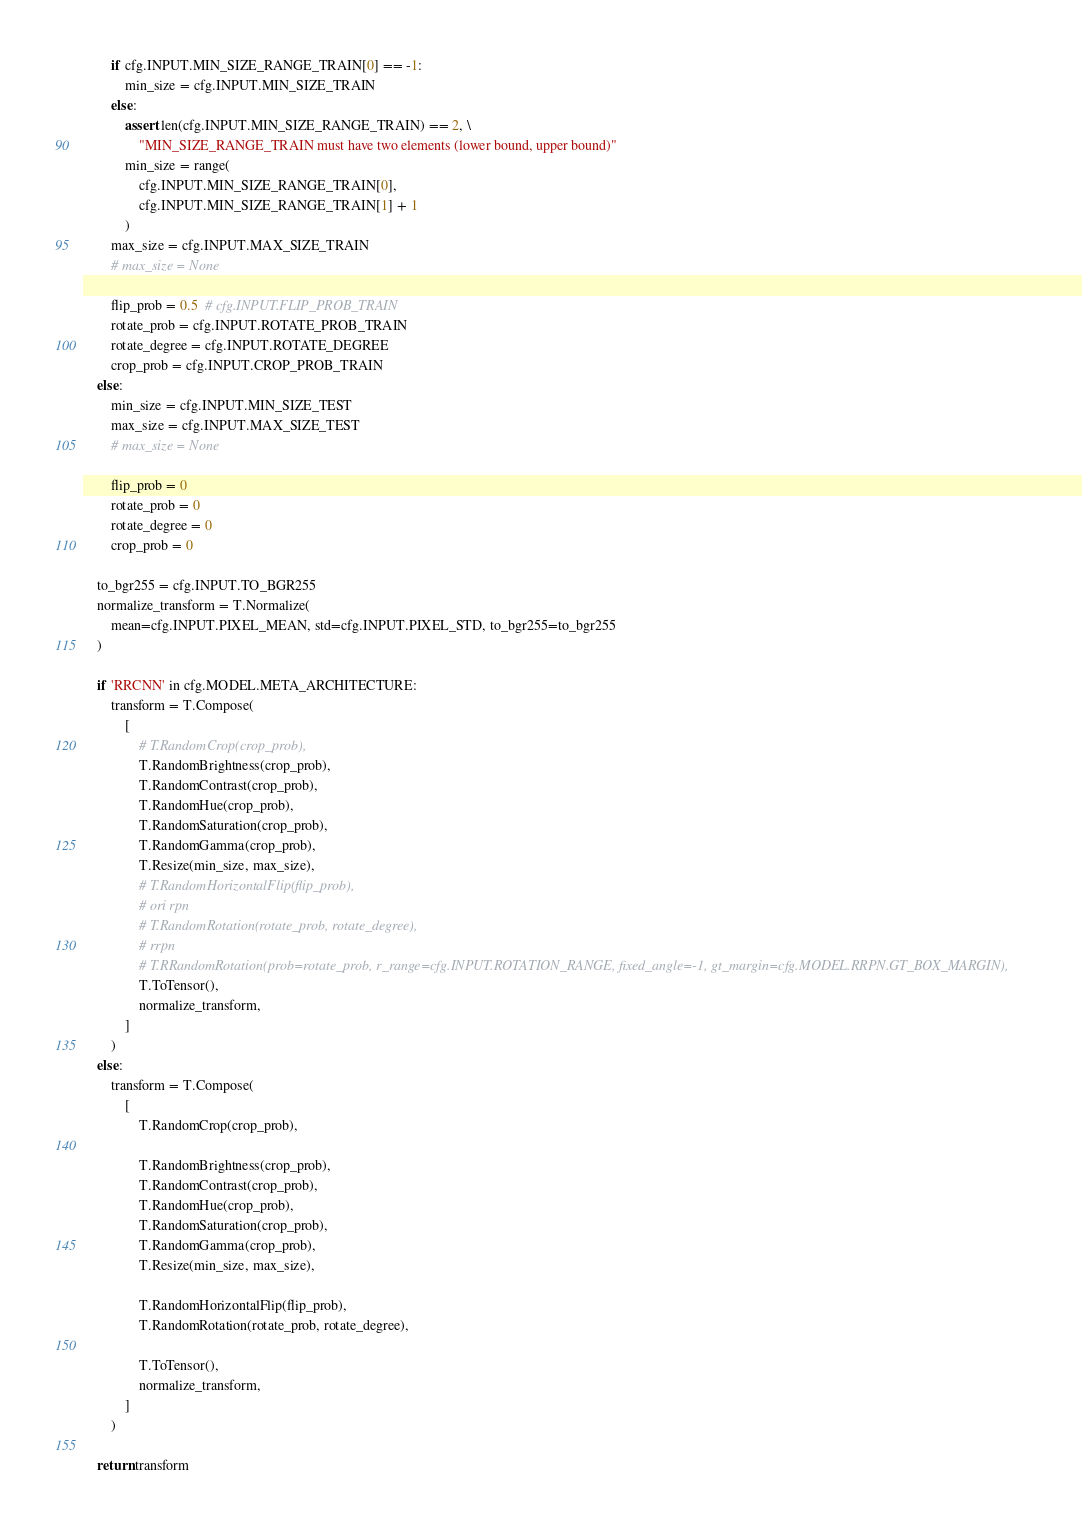<code> <loc_0><loc_0><loc_500><loc_500><_Python_>        if cfg.INPUT.MIN_SIZE_RANGE_TRAIN[0] == -1:
            min_size = cfg.INPUT.MIN_SIZE_TRAIN
        else:
            assert len(cfg.INPUT.MIN_SIZE_RANGE_TRAIN) == 2, \
                "MIN_SIZE_RANGE_TRAIN must have two elements (lower bound, upper bound)"
            min_size = range(
                cfg.INPUT.MIN_SIZE_RANGE_TRAIN[0],
                cfg.INPUT.MIN_SIZE_RANGE_TRAIN[1] + 1
            )
        max_size = cfg.INPUT.MAX_SIZE_TRAIN
        # max_size = None

        flip_prob = 0.5  # cfg.INPUT.FLIP_PROB_TRAIN
        rotate_prob = cfg.INPUT.ROTATE_PROB_TRAIN
        rotate_degree = cfg.INPUT.ROTATE_DEGREE
        crop_prob = cfg.INPUT.CROP_PROB_TRAIN
    else:
        min_size = cfg.INPUT.MIN_SIZE_TEST
        max_size = cfg.INPUT.MAX_SIZE_TEST
        # max_size = None

        flip_prob = 0
        rotate_prob = 0
        rotate_degree = 0
        crop_prob = 0

    to_bgr255 = cfg.INPUT.TO_BGR255
    normalize_transform = T.Normalize(
        mean=cfg.INPUT.PIXEL_MEAN, std=cfg.INPUT.PIXEL_STD, to_bgr255=to_bgr255
    )

    if 'RRCNN' in cfg.MODEL.META_ARCHITECTURE:
        transform = T.Compose(
            [
                # T.RandomCrop(crop_prob),
                T.RandomBrightness(crop_prob),
                T.RandomContrast(crop_prob),
                T.RandomHue(crop_prob),
                T.RandomSaturation(crop_prob),
                T.RandomGamma(crop_prob),
                T.Resize(min_size, max_size),
                # T.RandomHorizontalFlip(flip_prob),
                # ori rpn
                # T.RandomRotation(rotate_prob, rotate_degree),
                # rrpn
                # T.RRandomRotation(prob=rotate_prob, r_range=cfg.INPUT.ROTATION_RANGE, fixed_angle=-1, gt_margin=cfg.MODEL.RRPN.GT_BOX_MARGIN),
                T.ToTensor(),
                normalize_transform,
            ]
        )
    else:
        transform = T.Compose(
            [
                T.RandomCrop(crop_prob),

                T.RandomBrightness(crop_prob),
                T.RandomContrast(crop_prob),
                T.RandomHue(crop_prob),
                T.RandomSaturation(crop_prob),
                T.RandomGamma(crop_prob),
                T.Resize(min_size, max_size),

                T.RandomHorizontalFlip(flip_prob),
                T.RandomRotation(rotate_prob, rotate_degree),
                
                T.ToTensor(),
                normalize_transform,
            ]
        )
    
    return transform
</code> 